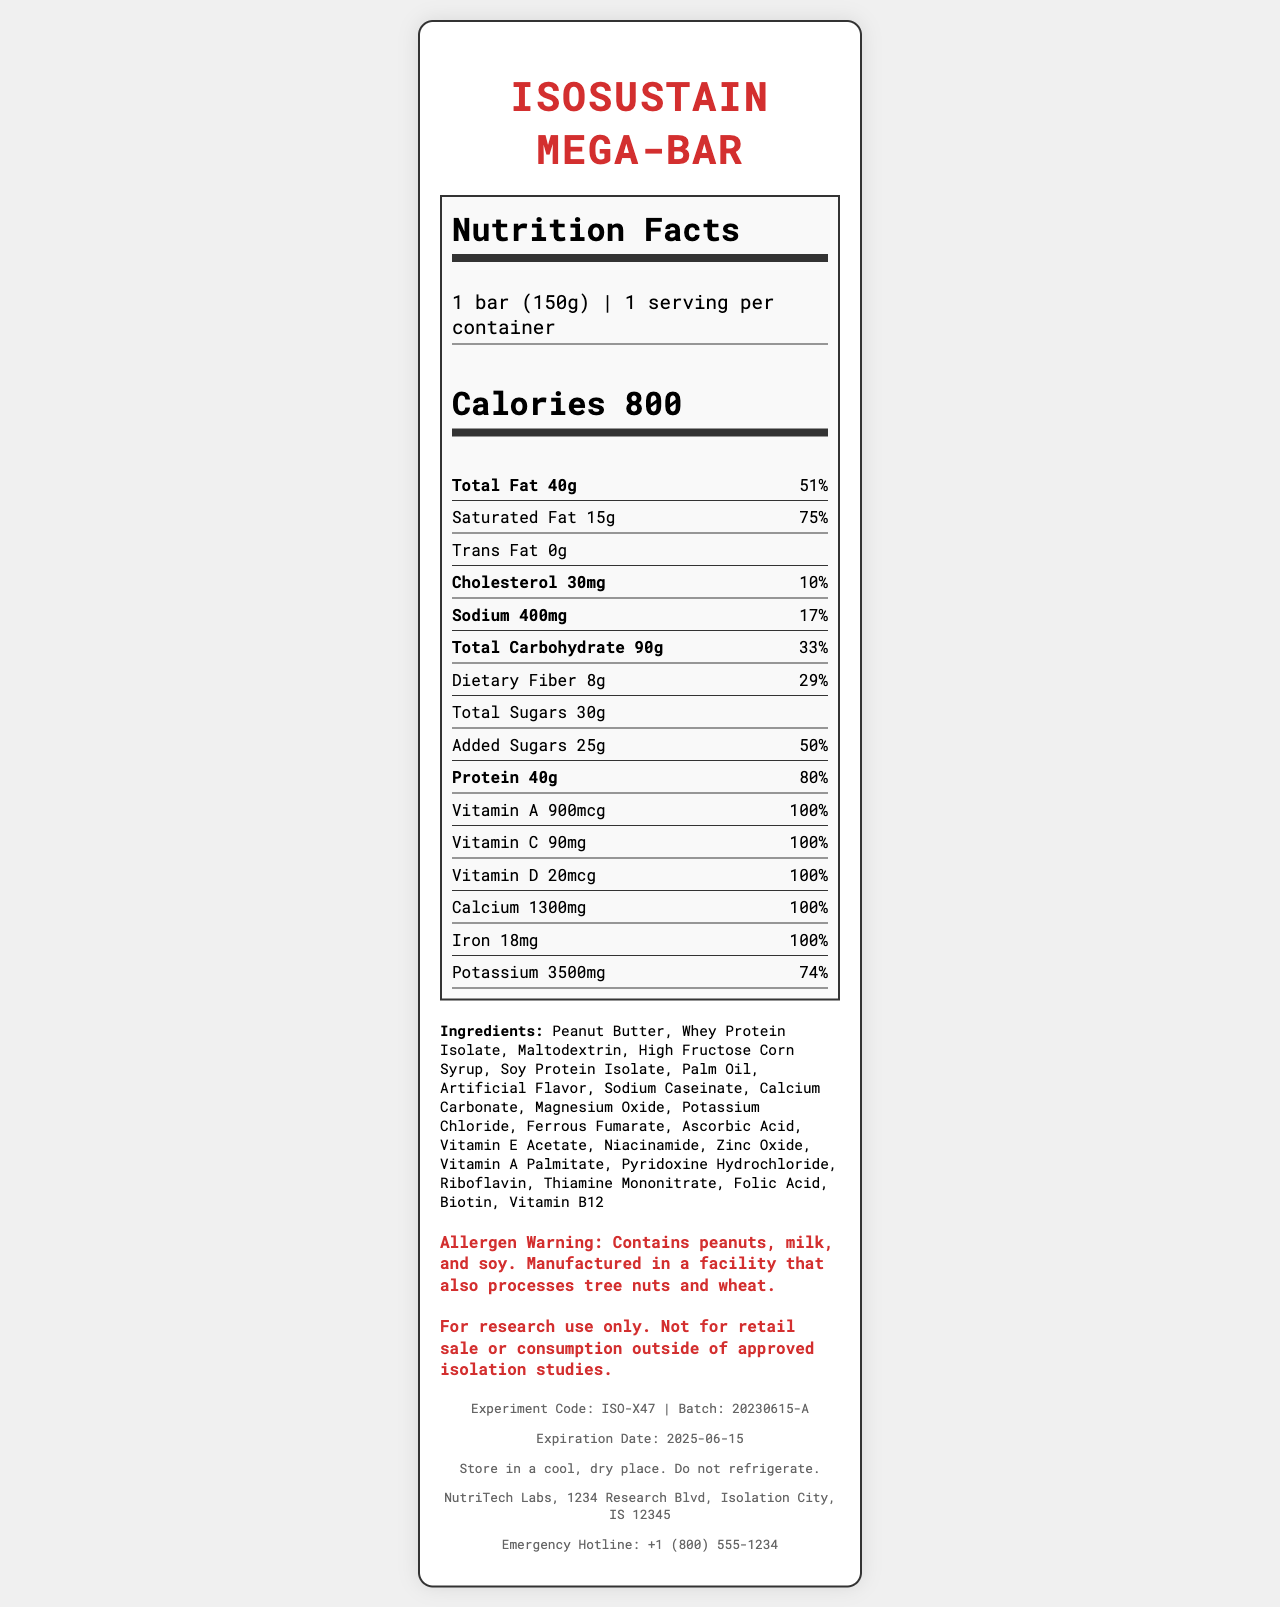what is the product name? The document clearly states the product name "IsoSustain Mega-Bar" at the top.
Answer: IsoSustain Mega-Bar what is the serving size? The serving size is mentioned under "servingSize" as "1 bar (150g)".
Answer: 1 bar (150g) how many calories are there per serving? The document lists "Calories 800" prominently in the Nutrition Facts label.
Answer: 800 what is the amount of protein in one serving? Under the nutrients list, protein content is specified as "40g".
Answer: 40g what is the daily value percentage for calcium? The document specifies that the daily value for calcium is 100%, with an amount of 1300mg.
Answer: 100% does the product contain any trans fat? The Nutrition Facts label lists "Trans Fat 0g," indicating there is no trans fat.
Answer: No which vitamin has the same daily value percentage as iron? A. Vitamin A B. Vitamin C C. Vitamin E D. Vitamin D Both Vitamin A and iron have a daily value percentage of 100%.
Answer: A. Vitamin A how much sodium is in the product? A. 200mg B. 300mg C. 400mg D. 500mg The document lists sodium content as "400mg" with a daily value of 17%.
Answer: C. 400mg is the product safe for people with nut allergies? The allergen warning states that the product contains peanuts and is manufactured in a facility that processes tree nuts.
Answer: No summarize the main idea of the document. This summary captures the various components and essential details presented in the document.
Answer: The document provides comprehensive nutritional information for the IsoSustain Mega-Bar, a high-calorie meal replacement bar designed for extended isolation studies. It includes serving sizes, caloric content, and detailed breakdowns of fats, carbohydrates, sugars, proteins, vitamins, and minerals. The label also highlights allergens, ingredient lists, and a disclaimer for research use only, indicating it is not for retail sale. Manufacturer and emergency contact information is also provided. what is the approximate expiration date of the product? The document specifies an expiration date as "2025-06-15".
Answer: June 15, 2025 where is the manufacturer located? The document lists the manufacturer's information towards the bottom, indicating the location as "NutriTech Labs, 1234 Research Blvd, Isolation City, IS 12345".
Answer: NutriTech Labs, 1234 Research Blvd, Isolation City, IS 12345 give a reason for the product's disclaimer. The disclaimer clearly states the product is intended for research use and not for general retail or unintended consumption.
Answer: For research use only. Not for retail sale or consumption outside of approved isolation studies. who is the manufacturer of the IsoSustain Mega-Bar? The document mentions "NutriTech Labs" as the manufacturer.
Answer: NutriTech Labs what is the storage instruction for the product? The document specifies how to store the product under storage instructions.
Answer: Store in a cool, dry place. Do not refrigerate. what are the first three ingredients listed? The first three ingredients listed in the ingredients section are "Peanut Butter, Whey Protein Isolate, Maltodextrin."
Answer: Peanut Butter, Whey Protein Isolate, Maltodextrin what is the experiment code associated with this product? The document contains an experiment code labeled "ISO-X47."
Answer: ISO-X47 what is the batch number of the IsoSustain Mega-Bar? The document mentions the batch number as "20230615-A."
Answer: 20230615-A is there information about the source of ingredients? The document does not provide any details about the source of ingredients.
Answer: Not enough information how does the document indicate the percentage for daily values? A. Using Numeric Values B. Using Percentages C. Using Both Numeric and Percentages The document indicates daily values using both numeric and percentage formats, e.g., "40g" and "51%".
Answer: C. Using Both Numeric and Percentages 